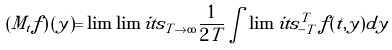Convert formula to latex. <formula><loc_0><loc_0><loc_500><loc_500>\left ( { M _ { t } f } \right ) ( y ) = \lim \lim i t s _ { T \to \infty } \frac { 1 } { 2 T } \int \lim i t s _ { - T } ^ { T } \, f ( t , y ) d y</formula> 